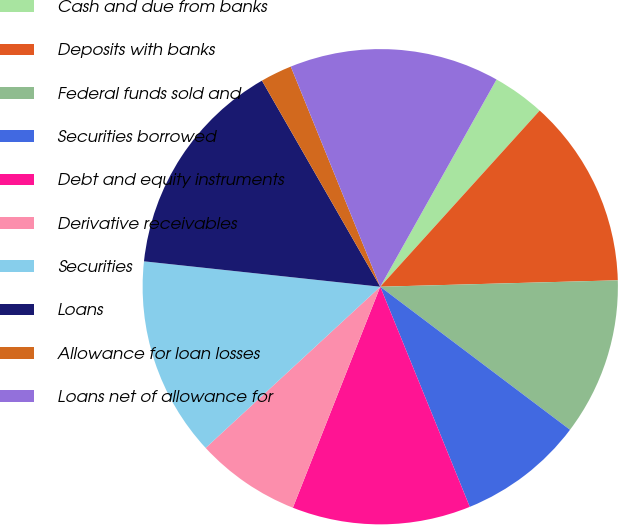Convert chart to OTSL. <chart><loc_0><loc_0><loc_500><loc_500><pie_chart><fcel>Cash and due from banks<fcel>Deposits with banks<fcel>Federal funds sold and<fcel>Securities borrowed<fcel>Debt and equity instruments<fcel>Derivative receivables<fcel>Securities<fcel>Loans<fcel>Allowance for loan losses<fcel>Loans net of allowance for<nl><fcel>3.57%<fcel>12.86%<fcel>10.71%<fcel>8.57%<fcel>12.14%<fcel>7.14%<fcel>13.57%<fcel>15.0%<fcel>2.15%<fcel>14.28%<nl></chart> 